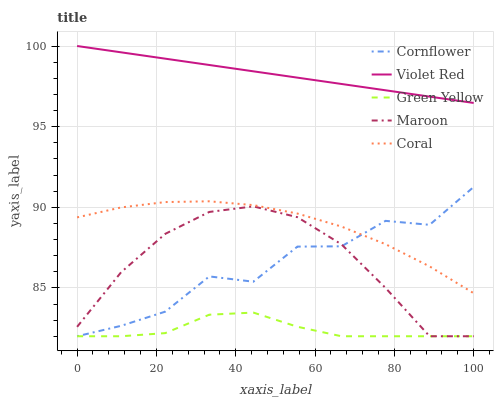Does Green Yellow have the minimum area under the curve?
Answer yes or no. Yes. Does Violet Red have the maximum area under the curve?
Answer yes or no. Yes. Does Violet Red have the minimum area under the curve?
Answer yes or no. No. Does Green Yellow have the maximum area under the curve?
Answer yes or no. No. Is Violet Red the smoothest?
Answer yes or no. Yes. Is Cornflower the roughest?
Answer yes or no. Yes. Is Green Yellow the smoothest?
Answer yes or no. No. Is Green Yellow the roughest?
Answer yes or no. No. Does Violet Red have the lowest value?
Answer yes or no. No. Does Violet Red have the highest value?
Answer yes or no. Yes. Does Green Yellow have the highest value?
Answer yes or no. No. Is Green Yellow less than Coral?
Answer yes or no. Yes. Is Coral greater than Green Yellow?
Answer yes or no. Yes. Does Cornflower intersect Coral?
Answer yes or no. Yes. Is Cornflower less than Coral?
Answer yes or no. No. Is Cornflower greater than Coral?
Answer yes or no. No. Does Green Yellow intersect Coral?
Answer yes or no. No. 